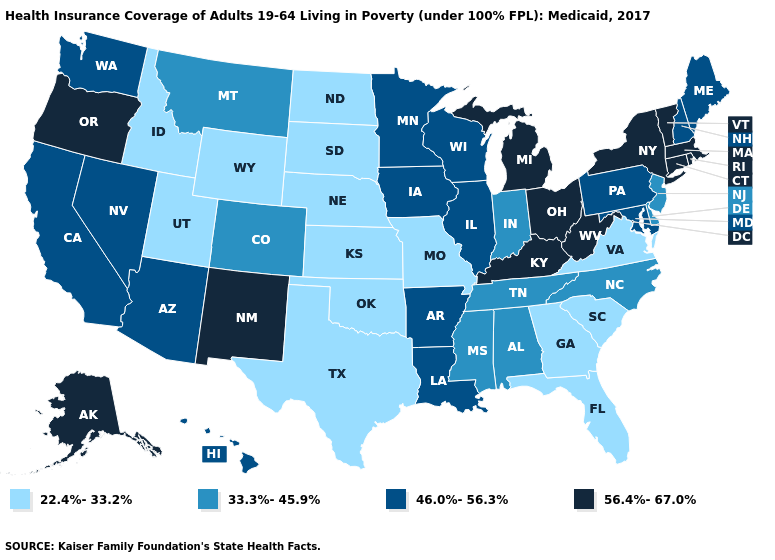Does Hawaii have the highest value in the USA?
Answer briefly. No. What is the value of Montana?
Keep it brief. 33.3%-45.9%. Is the legend a continuous bar?
Be succinct. No. What is the value of South Dakota?
Be succinct. 22.4%-33.2%. Name the states that have a value in the range 46.0%-56.3%?
Short answer required. Arizona, Arkansas, California, Hawaii, Illinois, Iowa, Louisiana, Maine, Maryland, Minnesota, Nevada, New Hampshire, Pennsylvania, Washington, Wisconsin. What is the value of Rhode Island?
Short answer required. 56.4%-67.0%. What is the value of Illinois?
Concise answer only. 46.0%-56.3%. Does Oklahoma have the lowest value in the USA?
Short answer required. Yes. Name the states that have a value in the range 56.4%-67.0%?
Concise answer only. Alaska, Connecticut, Kentucky, Massachusetts, Michigan, New Mexico, New York, Ohio, Oregon, Rhode Island, Vermont, West Virginia. Name the states that have a value in the range 22.4%-33.2%?
Answer briefly. Florida, Georgia, Idaho, Kansas, Missouri, Nebraska, North Dakota, Oklahoma, South Carolina, South Dakota, Texas, Utah, Virginia, Wyoming. What is the lowest value in states that border Michigan?
Keep it brief. 33.3%-45.9%. What is the highest value in the West ?
Be succinct. 56.4%-67.0%. Does Wyoming have the same value as Nebraska?
Keep it brief. Yes. What is the value of Wyoming?
Short answer required. 22.4%-33.2%. What is the value of New Jersey?
Write a very short answer. 33.3%-45.9%. 